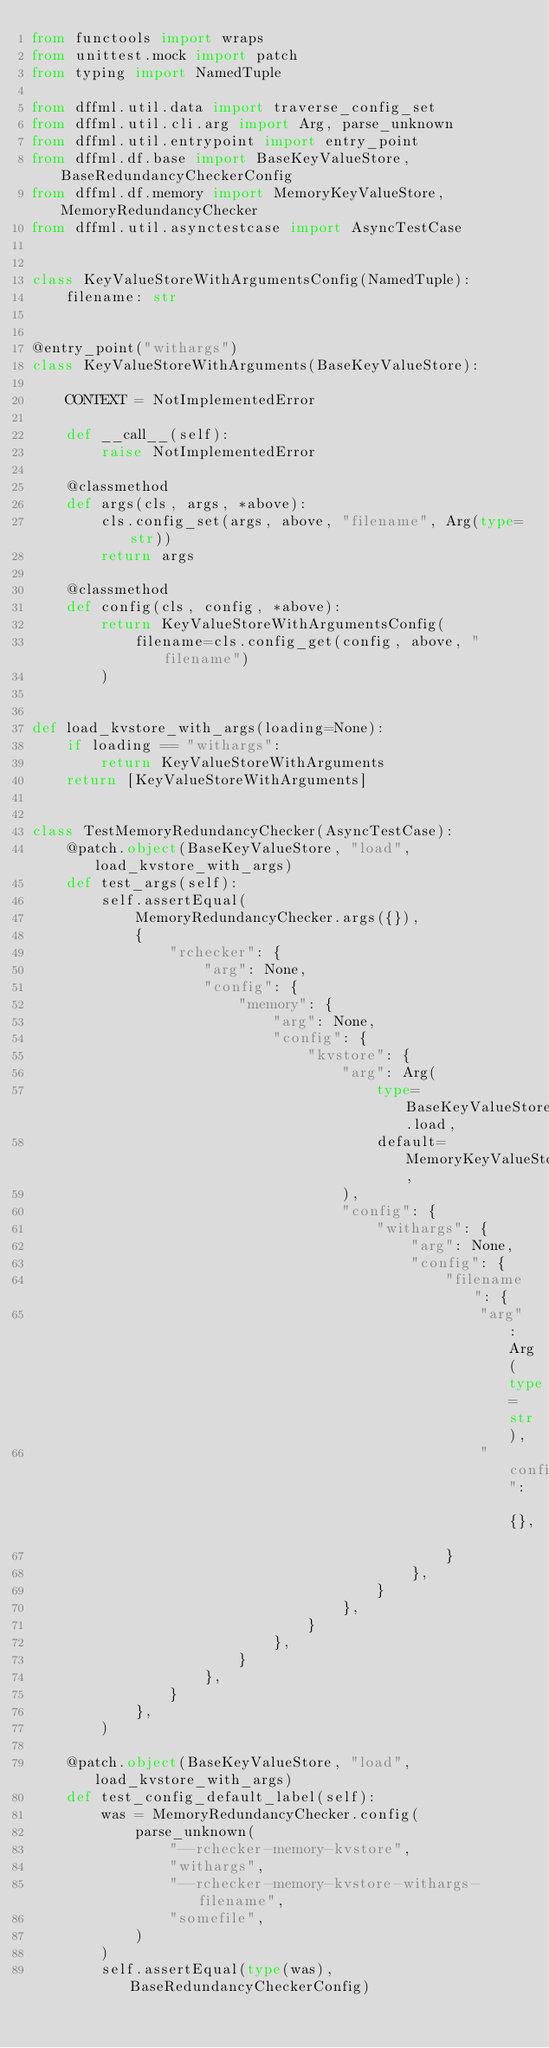Convert code to text. <code><loc_0><loc_0><loc_500><loc_500><_Python_>from functools import wraps
from unittest.mock import patch
from typing import NamedTuple

from dffml.util.data import traverse_config_set
from dffml.util.cli.arg import Arg, parse_unknown
from dffml.util.entrypoint import entry_point
from dffml.df.base import BaseKeyValueStore, BaseRedundancyCheckerConfig
from dffml.df.memory import MemoryKeyValueStore, MemoryRedundancyChecker
from dffml.util.asynctestcase import AsyncTestCase


class KeyValueStoreWithArgumentsConfig(NamedTuple):
    filename: str


@entry_point("withargs")
class KeyValueStoreWithArguments(BaseKeyValueStore):

    CONTEXT = NotImplementedError

    def __call__(self):
        raise NotImplementedError

    @classmethod
    def args(cls, args, *above):
        cls.config_set(args, above, "filename", Arg(type=str))
        return args

    @classmethod
    def config(cls, config, *above):
        return KeyValueStoreWithArgumentsConfig(
            filename=cls.config_get(config, above, "filename")
        )


def load_kvstore_with_args(loading=None):
    if loading == "withargs":
        return KeyValueStoreWithArguments
    return [KeyValueStoreWithArguments]


class TestMemoryRedundancyChecker(AsyncTestCase):
    @patch.object(BaseKeyValueStore, "load", load_kvstore_with_args)
    def test_args(self):
        self.assertEqual(
            MemoryRedundancyChecker.args({}),
            {
                "rchecker": {
                    "arg": None,
                    "config": {
                        "memory": {
                            "arg": None,
                            "config": {
                                "kvstore": {
                                    "arg": Arg(
                                        type=BaseKeyValueStore.load,
                                        default=MemoryKeyValueStore,
                                    ),
                                    "config": {
                                        "withargs": {
                                            "arg": None,
                                            "config": {
                                                "filename": {
                                                    "arg": Arg(type=str),
                                                    "config": {},
                                                }
                                            },
                                        }
                                    },
                                }
                            },
                        }
                    },
                }
            },
        )

    @patch.object(BaseKeyValueStore, "load", load_kvstore_with_args)
    def test_config_default_label(self):
        was = MemoryRedundancyChecker.config(
            parse_unknown(
                "--rchecker-memory-kvstore",
                "withargs",
                "--rchecker-memory-kvstore-withargs-filename",
                "somefile",
            )
        )
        self.assertEqual(type(was), BaseRedundancyCheckerConfig)</code> 